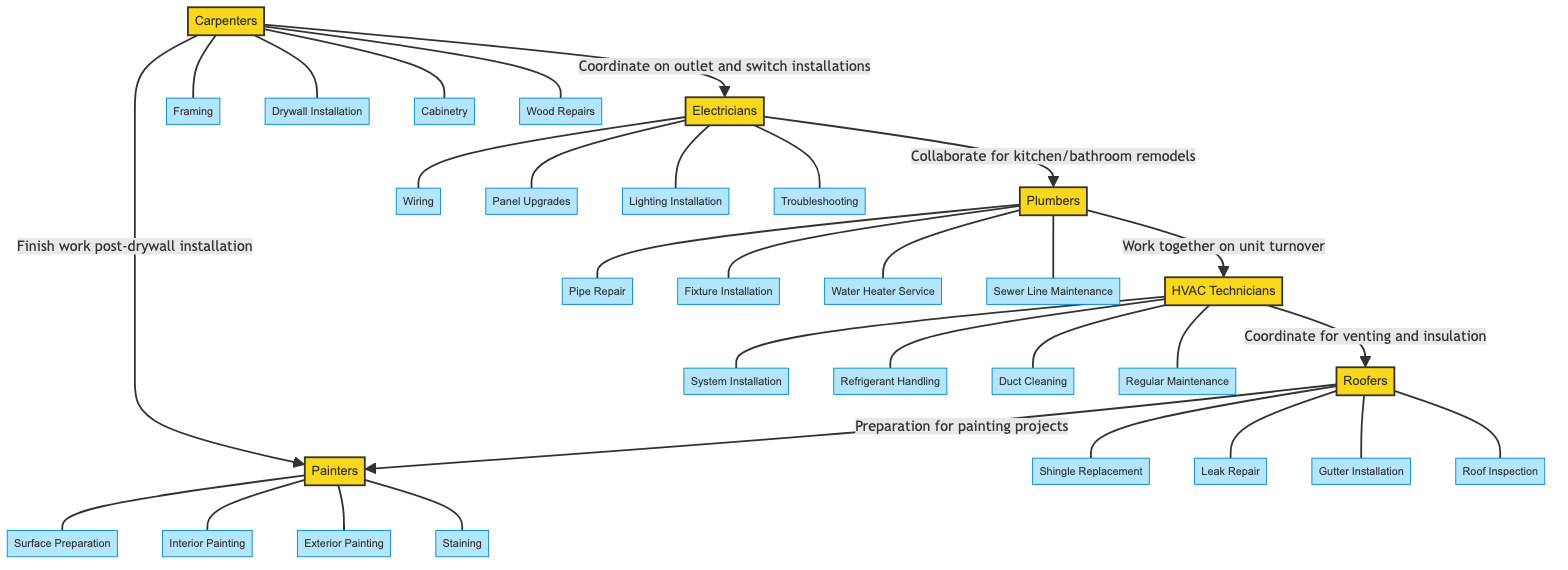What are the two skills of Electricians? The Electricians node lists four skills: Wiring, Panel Upgrades, Lighting Installation, and Troubleshooting. Picking any two from this list will work as the answer.
Answer: Wiring, Panel Upgrades Which contractor collaborates with Roofers? In the diagram, Roofers have a connection to Painters with the label "Preparation for painting projects." This indicates that Painters are the contractors collaborating with Roofers.
Answer: Painters How many skills does a Plumber have? The Plumbers node specifies four skills: Pipe Repair, Fixture Installation, Water Heater Service, and Sewer Line Maintenance. Thus, the number of skills is four.
Answer: 4 What type of work do Electricians and Carpenters coordinate on? The diagram shows that Electricians and Carpenters coordinate on outlet and switch installations, as indicated by the edge labeled "Coordinate on outlet and switch installations."
Answer: Outlet and switch installations Which contractor has the skill of Duct Cleaning? The skill of Duct Cleaning is listed under HVAC Technicians. Since the diagram connects this skill to the HVAC Technicians node, we identify this contractor as having that skill.
Answer: HVAC Technicians How many nodes are in this diagram? By counting the contractors listed (Electricians, Plumbers, HVAC Technicians, Carpenters, Roofers, and Painters), we observe a total of six nodes in the network diagram.
Answer: 6 What type of maintenance do Plumbers and HVAC Technicians work together on? The diagram indicates that Plumbers and HVAC Technicians work together on unit turnover, as shown by the edge labeled "Work together on unit turnover."
Answer: Unit turnover Which skills are associated with Painters? The Painters node identifies four skills: Surface Preparation, Interior Painting, Exterior Painting, and Staining. All of these skills are associated with Painters, specifically noted in the diagram.
Answer: Surface Preparation, Interior Painting, Exterior Painting, Staining What is the role of Roofers in relation to HVAC Technicians? Roofers coordinate with HVAC Technicians for venting and insulation, which is depicted by the edge labeled "Coordinate for venting and insulation." Hence, the role of Roofers is to collaborate in that context.
Answer: Coordinate for venting and insulation 